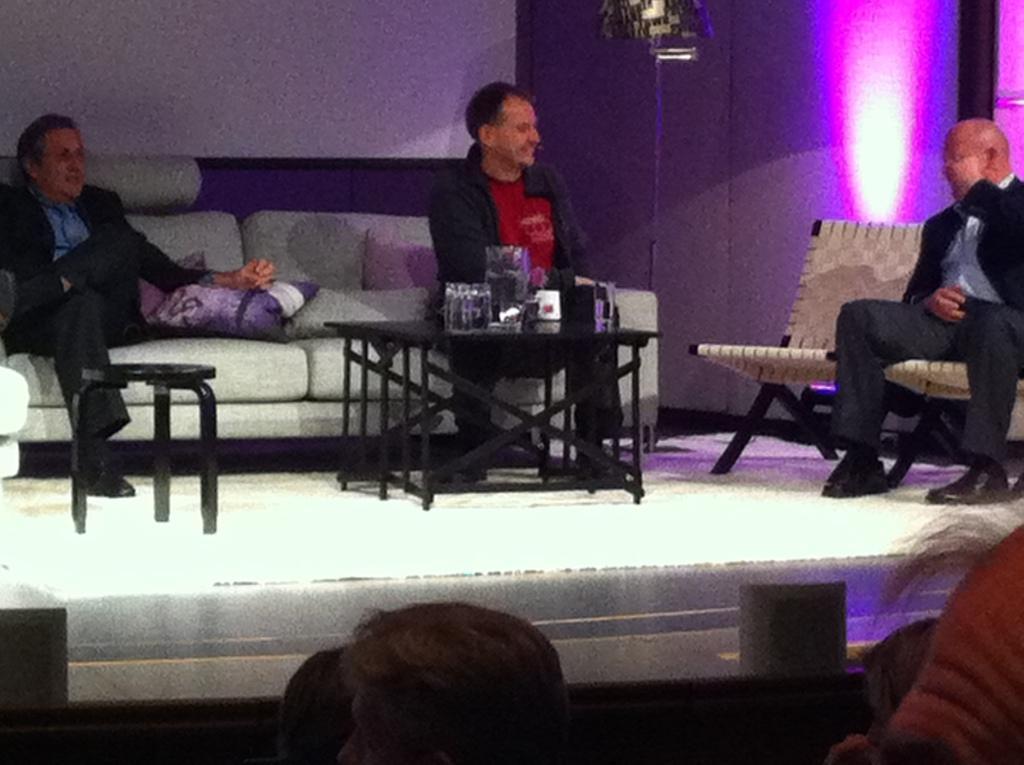Describe this image in one or two sentences. In this picture we can see three men sitting on sofa, chairs and here on table we can see glasses, jar and in front of them we have a group of people and in background we can see wall, light. 